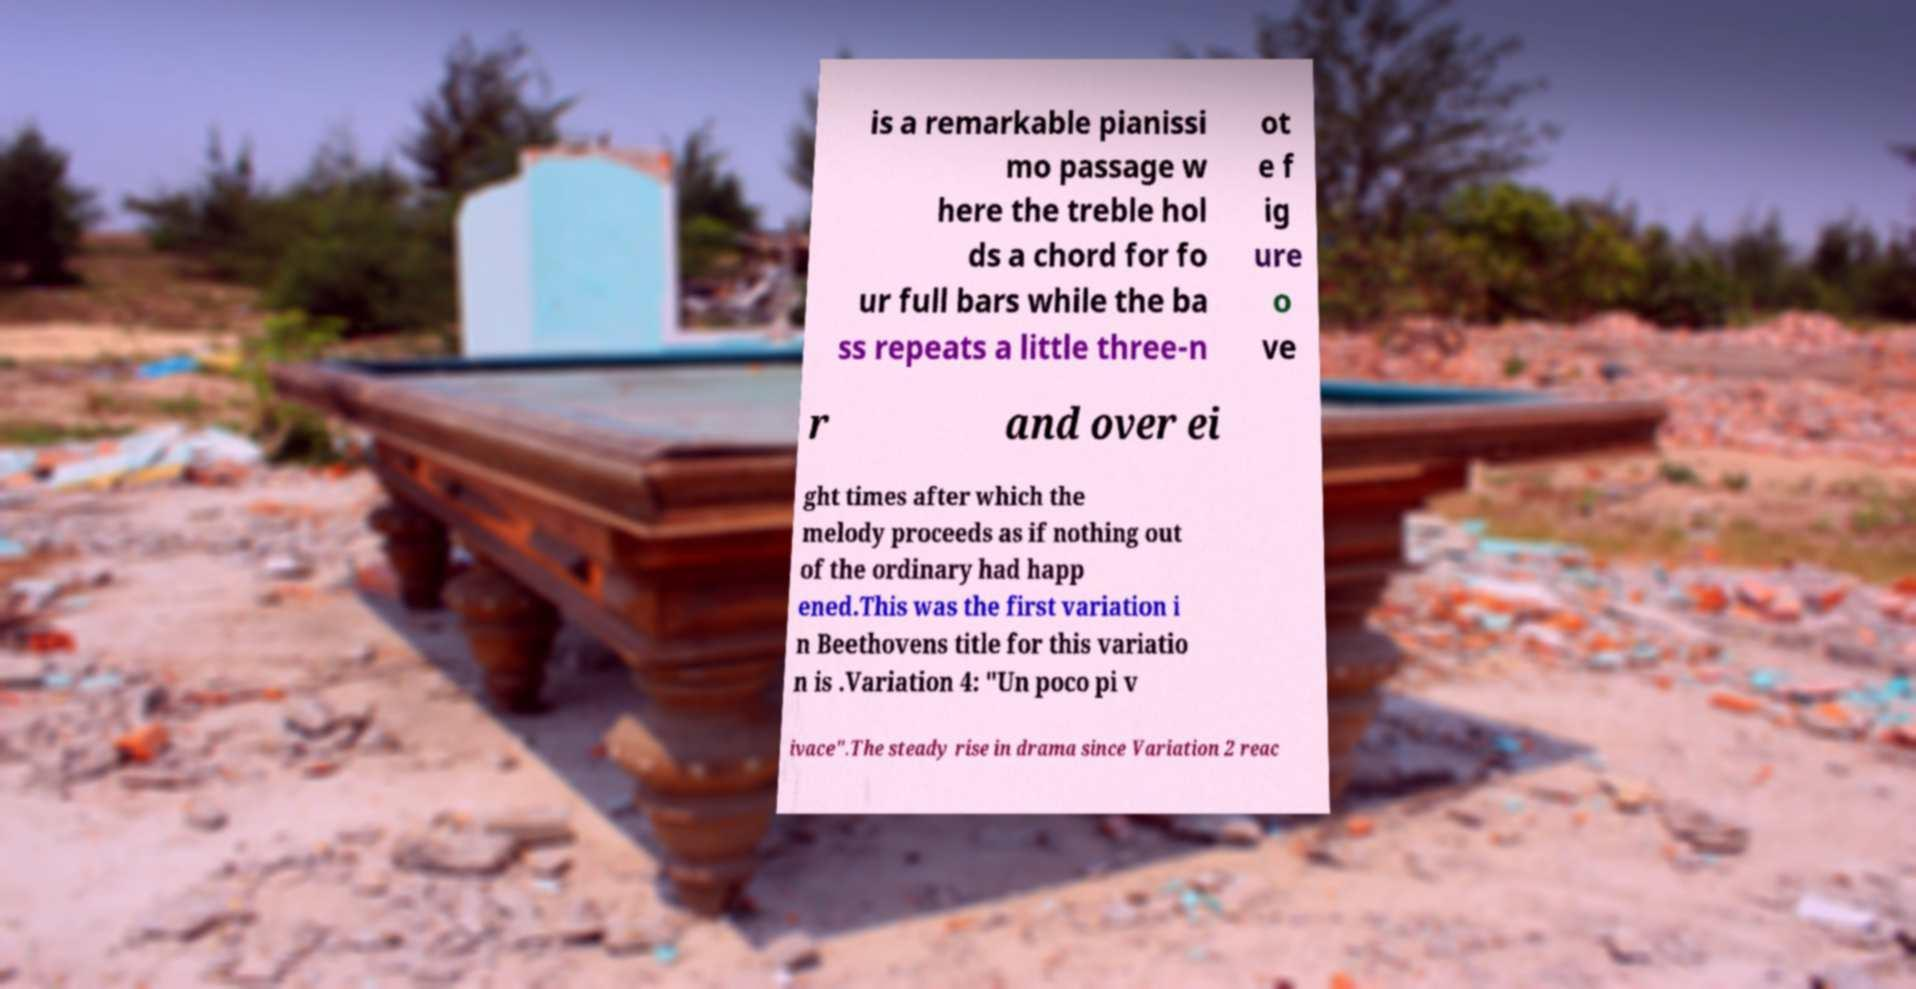Please identify and transcribe the text found in this image. is a remarkable pianissi mo passage w here the treble hol ds a chord for fo ur full bars while the ba ss repeats a little three-n ot e f ig ure o ve r and over ei ght times after which the melody proceeds as if nothing out of the ordinary had happ ened.This was the first variation i n Beethovens title for this variatio n is .Variation 4: "Un poco pi v ivace".The steady rise in drama since Variation 2 reac 